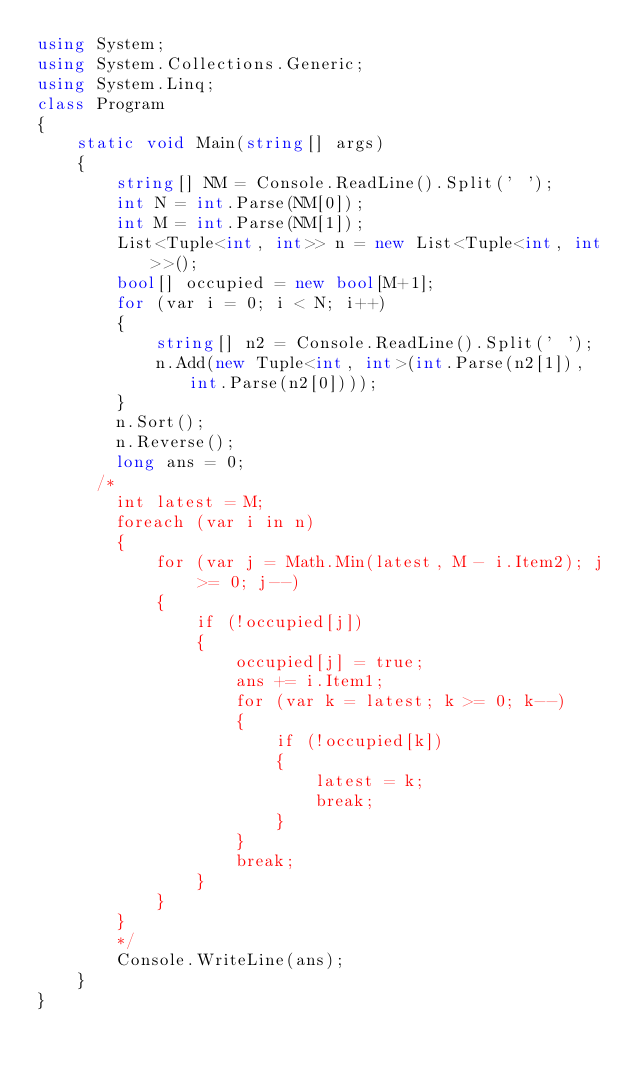<code> <loc_0><loc_0><loc_500><loc_500><_C#_>using System;
using System.Collections.Generic;
using System.Linq;
class Program
{
    static void Main(string[] args)
    {
        string[] NM = Console.ReadLine().Split(' ');
        int N = int.Parse(NM[0]);
        int M = int.Parse(NM[1]);
        List<Tuple<int, int>> n = new List<Tuple<int, int>>();
        bool[] occupied = new bool[M+1];
        for (var i = 0; i < N; i++)
        {
            string[] n2 = Console.ReadLine().Split(' ');
            n.Add(new Tuple<int, int>(int.Parse(n2[1]), int.Parse(n2[0])));
        }
        n.Sort();
        n.Reverse();
        long ans = 0;
      /*
        int latest = M;
        foreach (var i in n)
        {
            for (var j = Math.Min(latest, M - i.Item2); j >= 0; j--)
            {
                if (!occupied[j])
                {
                    occupied[j] = true;
                    ans += i.Item1;
                    for (var k = latest; k >= 0; k--)
                    {
                        if (!occupied[k])
                        {
                            latest = k;
                            break;
                        }
                    }
                    break;
                }
            }
        }
        */
        Console.WriteLine(ans);
    }
}</code> 